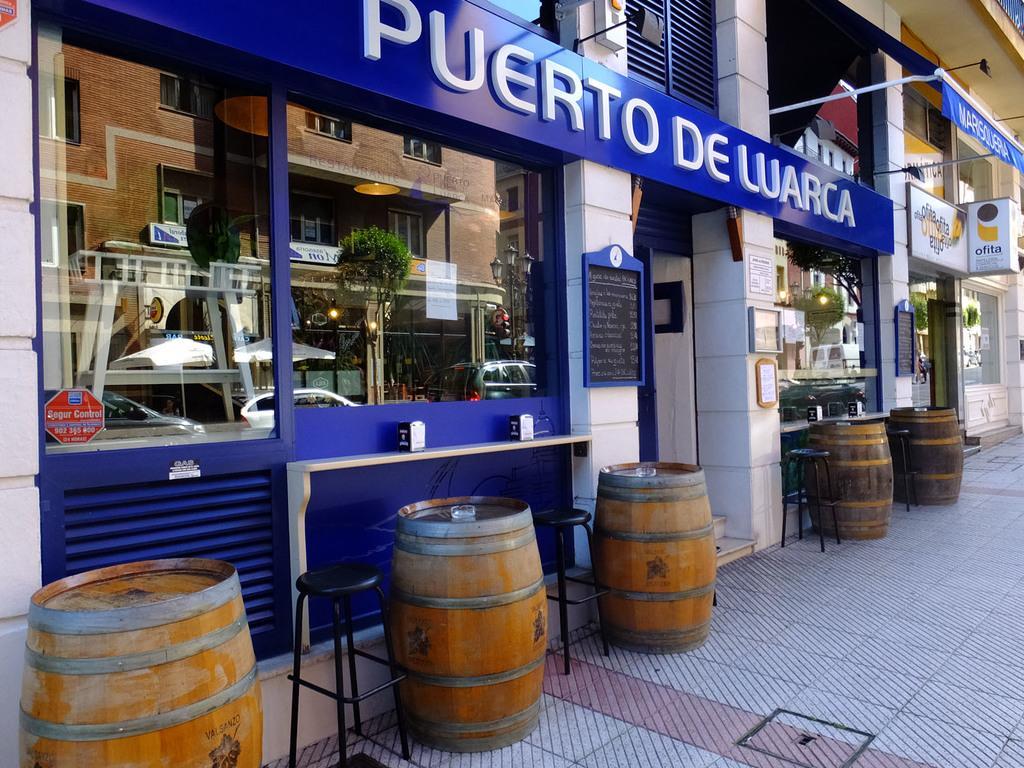Describe this image in one or two sentences. In the center of the image we can see building, stores, boards, light, pole, wall, drums, tables, cars, glass, windows, trees are present. At the bottom of the image ground is there. 